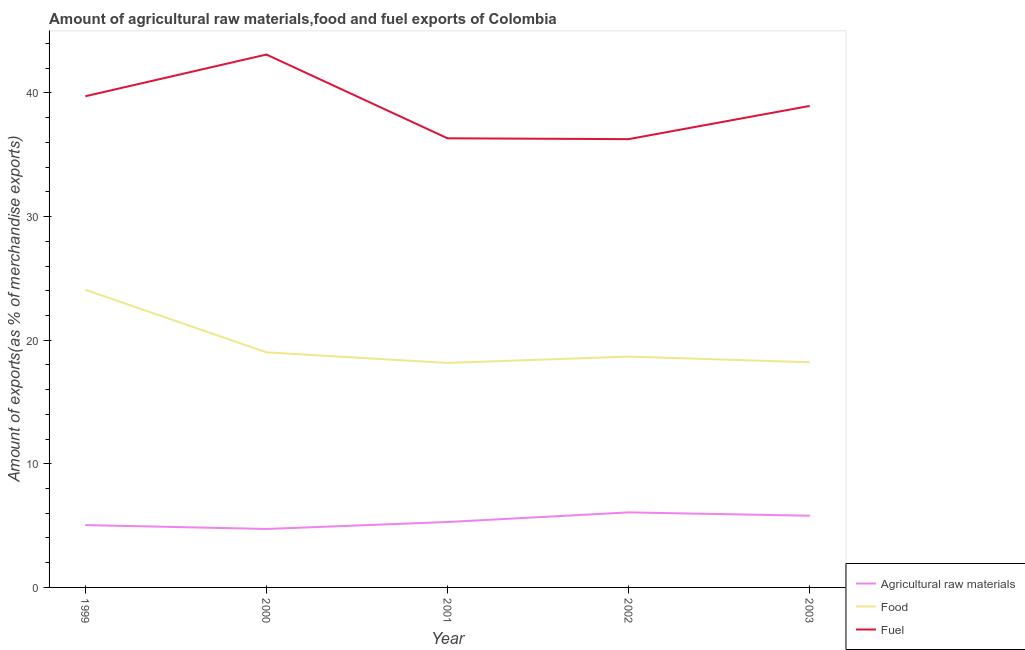How many different coloured lines are there?
Your answer should be very brief. 3. Does the line corresponding to percentage of food exports intersect with the line corresponding to percentage of fuel exports?
Your response must be concise. No. What is the percentage of raw materials exports in 2003?
Offer a very short reply. 5.8. Across all years, what is the maximum percentage of food exports?
Provide a short and direct response. 24.08. Across all years, what is the minimum percentage of fuel exports?
Offer a terse response. 36.27. In which year was the percentage of food exports maximum?
Offer a terse response. 1999. In which year was the percentage of fuel exports minimum?
Offer a terse response. 2002. What is the total percentage of fuel exports in the graph?
Your response must be concise. 194.4. What is the difference between the percentage of food exports in 2000 and that in 2001?
Provide a succinct answer. 0.86. What is the difference between the percentage of fuel exports in 2002 and the percentage of food exports in 2000?
Your answer should be compact. 17.25. What is the average percentage of raw materials exports per year?
Ensure brevity in your answer.  5.39. In the year 2002, what is the difference between the percentage of food exports and percentage of raw materials exports?
Your response must be concise. 12.6. In how many years, is the percentage of food exports greater than 30 %?
Offer a terse response. 0. What is the ratio of the percentage of fuel exports in 2000 to that in 2001?
Provide a short and direct response. 1.19. What is the difference between the highest and the second highest percentage of raw materials exports?
Ensure brevity in your answer.  0.27. What is the difference between the highest and the lowest percentage of food exports?
Offer a terse response. 5.92. In how many years, is the percentage of food exports greater than the average percentage of food exports taken over all years?
Your answer should be compact. 1. Is it the case that in every year, the sum of the percentage of raw materials exports and percentage of food exports is greater than the percentage of fuel exports?
Make the answer very short. No. Is the percentage of raw materials exports strictly less than the percentage of fuel exports over the years?
Your response must be concise. Yes. How many lines are there?
Provide a short and direct response. 3. Does the graph contain grids?
Your answer should be very brief. No. Where does the legend appear in the graph?
Make the answer very short. Bottom right. How many legend labels are there?
Your answer should be compact. 3. What is the title of the graph?
Keep it short and to the point. Amount of agricultural raw materials,food and fuel exports of Colombia. What is the label or title of the Y-axis?
Keep it short and to the point. Amount of exports(as % of merchandise exports). What is the Amount of exports(as % of merchandise exports) in Agricultural raw materials in 1999?
Provide a succinct answer. 5.04. What is the Amount of exports(as % of merchandise exports) in Food in 1999?
Ensure brevity in your answer.  24.08. What is the Amount of exports(as % of merchandise exports) of Fuel in 1999?
Keep it short and to the point. 39.74. What is the Amount of exports(as % of merchandise exports) of Agricultural raw materials in 2000?
Offer a terse response. 4.73. What is the Amount of exports(as % of merchandise exports) of Food in 2000?
Give a very brief answer. 19.02. What is the Amount of exports(as % of merchandise exports) in Fuel in 2000?
Provide a short and direct response. 43.11. What is the Amount of exports(as % of merchandise exports) in Agricultural raw materials in 2001?
Offer a very short reply. 5.29. What is the Amount of exports(as % of merchandise exports) in Food in 2001?
Provide a short and direct response. 18.16. What is the Amount of exports(as % of merchandise exports) of Fuel in 2001?
Your answer should be compact. 36.33. What is the Amount of exports(as % of merchandise exports) in Agricultural raw materials in 2002?
Offer a very short reply. 6.07. What is the Amount of exports(as % of merchandise exports) of Food in 2002?
Provide a short and direct response. 18.67. What is the Amount of exports(as % of merchandise exports) of Fuel in 2002?
Provide a short and direct response. 36.27. What is the Amount of exports(as % of merchandise exports) in Agricultural raw materials in 2003?
Your response must be concise. 5.8. What is the Amount of exports(as % of merchandise exports) in Food in 2003?
Ensure brevity in your answer.  18.22. What is the Amount of exports(as % of merchandise exports) of Fuel in 2003?
Give a very brief answer. 38.95. Across all years, what is the maximum Amount of exports(as % of merchandise exports) in Agricultural raw materials?
Your answer should be very brief. 6.07. Across all years, what is the maximum Amount of exports(as % of merchandise exports) in Food?
Make the answer very short. 24.08. Across all years, what is the maximum Amount of exports(as % of merchandise exports) of Fuel?
Keep it short and to the point. 43.11. Across all years, what is the minimum Amount of exports(as % of merchandise exports) in Agricultural raw materials?
Your response must be concise. 4.73. Across all years, what is the minimum Amount of exports(as % of merchandise exports) of Food?
Make the answer very short. 18.16. Across all years, what is the minimum Amount of exports(as % of merchandise exports) in Fuel?
Provide a short and direct response. 36.27. What is the total Amount of exports(as % of merchandise exports) of Agricultural raw materials in the graph?
Your answer should be compact. 26.94. What is the total Amount of exports(as % of merchandise exports) in Food in the graph?
Make the answer very short. 98.15. What is the total Amount of exports(as % of merchandise exports) of Fuel in the graph?
Ensure brevity in your answer.  194.4. What is the difference between the Amount of exports(as % of merchandise exports) of Agricultural raw materials in 1999 and that in 2000?
Your response must be concise. 0.32. What is the difference between the Amount of exports(as % of merchandise exports) of Food in 1999 and that in 2000?
Offer a terse response. 5.07. What is the difference between the Amount of exports(as % of merchandise exports) of Fuel in 1999 and that in 2000?
Your answer should be very brief. -3.37. What is the difference between the Amount of exports(as % of merchandise exports) of Agricultural raw materials in 1999 and that in 2001?
Offer a very short reply. -0.25. What is the difference between the Amount of exports(as % of merchandise exports) of Food in 1999 and that in 2001?
Make the answer very short. 5.92. What is the difference between the Amount of exports(as % of merchandise exports) in Fuel in 1999 and that in 2001?
Your answer should be compact. 3.4. What is the difference between the Amount of exports(as % of merchandise exports) in Agricultural raw materials in 1999 and that in 2002?
Your answer should be very brief. -1.03. What is the difference between the Amount of exports(as % of merchandise exports) of Food in 1999 and that in 2002?
Provide a short and direct response. 5.41. What is the difference between the Amount of exports(as % of merchandise exports) in Fuel in 1999 and that in 2002?
Provide a succinct answer. 3.47. What is the difference between the Amount of exports(as % of merchandise exports) of Agricultural raw materials in 1999 and that in 2003?
Give a very brief answer. -0.76. What is the difference between the Amount of exports(as % of merchandise exports) in Food in 1999 and that in 2003?
Your response must be concise. 5.87. What is the difference between the Amount of exports(as % of merchandise exports) of Fuel in 1999 and that in 2003?
Provide a short and direct response. 0.78. What is the difference between the Amount of exports(as % of merchandise exports) of Agricultural raw materials in 2000 and that in 2001?
Give a very brief answer. -0.56. What is the difference between the Amount of exports(as % of merchandise exports) in Food in 2000 and that in 2001?
Provide a succinct answer. 0.86. What is the difference between the Amount of exports(as % of merchandise exports) in Fuel in 2000 and that in 2001?
Provide a succinct answer. 6.78. What is the difference between the Amount of exports(as % of merchandise exports) of Agricultural raw materials in 2000 and that in 2002?
Ensure brevity in your answer.  -1.34. What is the difference between the Amount of exports(as % of merchandise exports) in Food in 2000 and that in 2002?
Provide a short and direct response. 0.34. What is the difference between the Amount of exports(as % of merchandise exports) of Fuel in 2000 and that in 2002?
Your answer should be compact. 6.84. What is the difference between the Amount of exports(as % of merchandise exports) of Agricultural raw materials in 2000 and that in 2003?
Give a very brief answer. -1.07. What is the difference between the Amount of exports(as % of merchandise exports) of Food in 2000 and that in 2003?
Make the answer very short. 0.8. What is the difference between the Amount of exports(as % of merchandise exports) in Fuel in 2000 and that in 2003?
Your answer should be compact. 4.16. What is the difference between the Amount of exports(as % of merchandise exports) of Agricultural raw materials in 2001 and that in 2002?
Your response must be concise. -0.78. What is the difference between the Amount of exports(as % of merchandise exports) in Food in 2001 and that in 2002?
Provide a short and direct response. -0.51. What is the difference between the Amount of exports(as % of merchandise exports) of Fuel in 2001 and that in 2002?
Provide a succinct answer. 0.07. What is the difference between the Amount of exports(as % of merchandise exports) of Agricultural raw materials in 2001 and that in 2003?
Your answer should be very brief. -0.51. What is the difference between the Amount of exports(as % of merchandise exports) in Food in 2001 and that in 2003?
Your answer should be compact. -0.06. What is the difference between the Amount of exports(as % of merchandise exports) in Fuel in 2001 and that in 2003?
Your answer should be compact. -2.62. What is the difference between the Amount of exports(as % of merchandise exports) in Agricultural raw materials in 2002 and that in 2003?
Your answer should be compact. 0.27. What is the difference between the Amount of exports(as % of merchandise exports) in Food in 2002 and that in 2003?
Your response must be concise. 0.46. What is the difference between the Amount of exports(as % of merchandise exports) of Fuel in 2002 and that in 2003?
Ensure brevity in your answer.  -2.69. What is the difference between the Amount of exports(as % of merchandise exports) in Agricultural raw materials in 1999 and the Amount of exports(as % of merchandise exports) in Food in 2000?
Offer a very short reply. -13.97. What is the difference between the Amount of exports(as % of merchandise exports) in Agricultural raw materials in 1999 and the Amount of exports(as % of merchandise exports) in Fuel in 2000?
Ensure brevity in your answer.  -38.07. What is the difference between the Amount of exports(as % of merchandise exports) in Food in 1999 and the Amount of exports(as % of merchandise exports) in Fuel in 2000?
Your answer should be very brief. -19.03. What is the difference between the Amount of exports(as % of merchandise exports) of Agricultural raw materials in 1999 and the Amount of exports(as % of merchandise exports) of Food in 2001?
Offer a terse response. -13.12. What is the difference between the Amount of exports(as % of merchandise exports) of Agricultural raw materials in 1999 and the Amount of exports(as % of merchandise exports) of Fuel in 2001?
Ensure brevity in your answer.  -31.29. What is the difference between the Amount of exports(as % of merchandise exports) in Food in 1999 and the Amount of exports(as % of merchandise exports) in Fuel in 2001?
Offer a terse response. -12.25. What is the difference between the Amount of exports(as % of merchandise exports) of Agricultural raw materials in 1999 and the Amount of exports(as % of merchandise exports) of Food in 2002?
Offer a terse response. -13.63. What is the difference between the Amount of exports(as % of merchandise exports) in Agricultural raw materials in 1999 and the Amount of exports(as % of merchandise exports) in Fuel in 2002?
Make the answer very short. -31.22. What is the difference between the Amount of exports(as % of merchandise exports) of Food in 1999 and the Amount of exports(as % of merchandise exports) of Fuel in 2002?
Provide a succinct answer. -12.18. What is the difference between the Amount of exports(as % of merchandise exports) of Agricultural raw materials in 1999 and the Amount of exports(as % of merchandise exports) of Food in 2003?
Make the answer very short. -13.17. What is the difference between the Amount of exports(as % of merchandise exports) of Agricultural raw materials in 1999 and the Amount of exports(as % of merchandise exports) of Fuel in 2003?
Your answer should be very brief. -33.91. What is the difference between the Amount of exports(as % of merchandise exports) in Food in 1999 and the Amount of exports(as % of merchandise exports) in Fuel in 2003?
Give a very brief answer. -14.87. What is the difference between the Amount of exports(as % of merchandise exports) of Agricultural raw materials in 2000 and the Amount of exports(as % of merchandise exports) of Food in 2001?
Provide a succinct answer. -13.43. What is the difference between the Amount of exports(as % of merchandise exports) of Agricultural raw materials in 2000 and the Amount of exports(as % of merchandise exports) of Fuel in 2001?
Offer a very short reply. -31.61. What is the difference between the Amount of exports(as % of merchandise exports) of Food in 2000 and the Amount of exports(as % of merchandise exports) of Fuel in 2001?
Your answer should be compact. -17.32. What is the difference between the Amount of exports(as % of merchandise exports) of Agricultural raw materials in 2000 and the Amount of exports(as % of merchandise exports) of Food in 2002?
Offer a terse response. -13.94. What is the difference between the Amount of exports(as % of merchandise exports) in Agricultural raw materials in 2000 and the Amount of exports(as % of merchandise exports) in Fuel in 2002?
Offer a very short reply. -31.54. What is the difference between the Amount of exports(as % of merchandise exports) in Food in 2000 and the Amount of exports(as % of merchandise exports) in Fuel in 2002?
Keep it short and to the point. -17.25. What is the difference between the Amount of exports(as % of merchandise exports) in Agricultural raw materials in 2000 and the Amount of exports(as % of merchandise exports) in Food in 2003?
Provide a short and direct response. -13.49. What is the difference between the Amount of exports(as % of merchandise exports) of Agricultural raw materials in 2000 and the Amount of exports(as % of merchandise exports) of Fuel in 2003?
Your answer should be compact. -34.22. What is the difference between the Amount of exports(as % of merchandise exports) of Food in 2000 and the Amount of exports(as % of merchandise exports) of Fuel in 2003?
Provide a short and direct response. -19.94. What is the difference between the Amount of exports(as % of merchandise exports) of Agricultural raw materials in 2001 and the Amount of exports(as % of merchandise exports) of Food in 2002?
Offer a terse response. -13.38. What is the difference between the Amount of exports(as % of merchandise exports) in Agricultural raw materials in 2001 and the Amount of exports(as % of merchandise exports) in Fuel in 2002?
Offer a very short reply. -30.97. What is the difference between the Amount of exports(as % of merchandise exports) of Food in 2001 and the Amount of exports(as % of merchandise exports) of Fuel in 2002?
Provide a succinct answer. -18.11. What is the difference between the Amount of exports(as % of merchandise exports) in Agricultural raw materials in 2001 and the Amount of exports(as % of merchandise exports) in Food in 2003?
Offer a terse response. -12.92. What is the difference between the Amount of exports(as % of merchandise exports) of Agricultural raw materials in 2001 and the Amount of exports(as % of merchandise exports) of Fuel in 2003?
Provide a succinct answer. -33.66. What is the difference between the Amount of exports(as % of merchandise exports) in Food in 2001 and the Amount of exports(as % of merchandise exports) in Fuel in 2003?
Make the answer very short. -20.79. What is the difference between the Amount of exports(as % of merchandise exports) of Agricultural raw materials in 2002 and the Amount of exports(as % of merchandise exports) of Food in 2003?
Your response must be concise. -12.15. What is the difference between the Amount of exports(as % of merchandise exports) in Agricultural raw materials in 2002 and the Amount of exports(as % of merchandise exports) in Fuel in 2003?
Your answer should be compact. -32.88. What is the difference between the Amount of exports(as % of merchandise exports) of Food in 2002 and the Amount of exports(as % of merchandise exports) of Fuel in 2003?
Offer a terse response. -20.28. What is the average Amount of exports(as % of merchandise exports) in Agricultural raw materials per year?
Provide a succinct answer. 5.39. What is the average Amount of exports(as % of merchandise exports) of Food per year?
Your answer should be very brief. 19.63. What is the average Amount of exports(as % of merchandise exports) in Fuel per year?
Your answer should be very brief. 38.88. In the year 1999, what is the difference between the Amount of exports(as % of merchandise exports) of Agricultural raw materials and Amount of exports(as % of merchandise exports) of Food?
Provide a succinct answer. -19.04. In the year 1999, what is the difference between the Amount of exports(as % of merchandise exports) of Agricultural raw materials and Amount of exports(as % of merchandise exports) of Fuel?
Your answer should be compact. -34.69. In the year 1999, what is the difference between the Amount of exports(as % of merchandise exports) of Food and Amount of exports(as % of merchandise exports) of Fuel?
Provide a succinct answer. -15.65. In the year 2000, what is the difference between the Amount of exports(as % of merchandise exports) in Agricultural raw materials and Amount of exports(as % of merchandise exports) in Food?
Offer a terse response. -14.29. In the year 2000, what is the difference between the Amount of exports(as % of merchandise exports) of Agricultural raw materials and Amount of exports(as % of merchandise exports) of Fuel?
Provide a short and direct response. -38.38. In the year 2000, what is the difference between the Amount of exports(as % of merchandise exports) in Food and Amount of exports(as % of merchandise exports) in Fuel?
Offer a very short reply. -24.09. In the year 2001, what is the difference between the Amount of exports(as % of merchandise exports) in Agricultural raw materials and Amount of exports(as % of merchandise exports) in Food?
Keep it short and to the point. -12.87. In the year 2001, what is the difference between the Amount of exports(as % of merchandise exports) of Agricultural raw materials and Amount of exports(as % of merchandise exports) of Fuel?
Provide a succinct answer. -31.04. In the year 2001, what is the difference between the Amount of exports(as % of merchandise exports) in Food and Amount of exports(as % of merchandise exports) in Fuel?
Give a very brief answer. -18.17. In the year 2002, what is the difference between the Amount of exports(as % of merchandise exports) of Agricultural raw materials and Amount of exports(as % of merchandise exports) of Food?
Keep it short and to the point. -12.6. In the year 2002, what is the difference between the Amount of exports(as % of merchandise exports) of Agricultural raw materials and Amount of exports(as % of merchandise exports) of Fuel?
Provide a succinct answer. -30.2. In the year 2002, what is the difference between the Amount of exports(as % of merchandise exports) in Food and Amount of exports(as % of merchandise exports) in Fuel?
Ensure brevity in your answer.  -17.59. In the year 2003, what is the difference between the Amount of exports(as % of merchandise exports) of Agricultural raw materials and Amount of exports(as % of merchandise exports) of Food?
Ensure brevity in your answer.  -12.42. In the year 2003, what is the difference between the Amount of exports(as % of merchandise exports) in Agricultural raw materials and Amount of exports(as % of merchandise exports) in Fuel?
Ensure brevity in your answer.  -33.15. In the year 2003, what is the difference between the Amount of exports(as % of merchandise exports) in Food and Amount of exports(as % of merchandise exports) in Fuel?
Provide a succinct answer. -20.74. What is the ratio of the Amount of exports(as % of merchandise exports) in Agricultural raw materials in 1999 to that in 2000?
Make the answer very short. 1.07. What is the ratio of the Amount of exports(as % of merchandise exports) in Food in 1999 to that in 2000?
Your answer should be very brief. 1.27. What is the ratio of the Amount of exports(as % of merchandise exports) in Fuel in 1999 to that in 2000?
Your answer should be very brief. 0.92. What is the ratio of the Amount of exports(as % of merchandise exports) in Agricultural raw materials in 1999 to that in 2001?
Provide a succinct answer. 0.95. What is the ratio of the Amount of exports(as % of merchandise exports) in Food in 1999 to that in 2001?
Keep it short and to the point. 1.33. What is the ratio of the Amount of exports(as % of merchandise exports) of Fuel in 1999 to that in 2001?
Provide a short and direct response. 1.09. What is the ratio of the Amount of exports(as % of merchandise exports) in Agricultural raw materials in 1999 to that in 2002?
Ensure brevity in your answer.  0.83. What is the ratio of the Amount of exports(as % of merchandise exports) of Food in 1999 to that in 2002?
Give a very brief answer. 1.29. What is the ratio of the Amount of exports(as % of merchandise exports) in Fuel in 1999 to that in 2002?
Give a very brief answer. 1.1. What is the ratio of the Amount of exports(as % of merchandise exports) of Agricultural raw materials in 1999 to that in 2003?
Your response must be concise. 0.87. What is the ratio of the Amount of exports(as % of merchandise exports) in Food in 1999 to that in 2003?
Your answer should be compact. 1.32. What is the ratio of the Amount of exports(as % of merchandise exports) in Fuel in 1999 to that in 2003?
Your response must be concise. 1.02. What is the ratio of the Amount of exports(as % of merchandise exports) of Agricultural raw materials in 2000 to that in 2001?
Ensure brevity in your answer.  0.89. What is the ratio of the Amount of exports(as % of merchandise exports) in Food in 2000 to that in 2001?
Ensure brevity in your answer.  1.05. What is the ratio of the Amount of exports(as % of merchandise exports) of Fuel in 2000 to that in 2001?
Make the answer very short. 1.19. What is the ratio of the Amount of exports(as % of merchandise exports) of Agricultural raw materials in 2000 to that in 2002?
Your answer should be very brief. 0.78. What is the ratio of the Amount of exports(as % of merchandise exports) of Food in 2000 to that in 2002?
Keep it short and to the point. 1.02. What is the ratio of the Amount of exports(as % of merchandise exports) in Fuel in 2000 to that in 2002?
Keep it short and to the point. 1.19. What is the ratio of the Amount of exports(as % of merchandise exports) of Agricultural raw materials in 2000 to that in 2003?
Offer a terse response. 0.82. What is the ratio of the Amount of exports(as % of merchandise exports) in Food in 2000 to that in 2003?
Your answer should be compact. 1.04. What is the ratio of the Amount of exports(as % of merchandise exports) in Fuel in 2000 to that in 2003?
Provide a succinct answer. 1.11. What is the ratio of the Amount of exports(as % of merchandise exports) in Agricultural raw materials in 2001 to that in 2002?
Your answer should be compact. 0.87. What is the ratio of the Amount of exports(as % of merchandise exports) in Food in 2001 to that in 2002?
Provide a short and direct response. 0.97. What is the ratio of the Amount of exports(as % of merchandise exports) of Agricultural raw materials in 2001 to that in 2003?
Your answer should be compact. 0.91. What is the ratio of the Amount of exports(as % of merchandise exports) in Food in 2001 to that in 2003?
Give a very brief answer. 1. What is the ratio of the Amount of exports(as % of merchandise exports) of Fuel in 2001 to that in 2003?
Offer a very short reply. 0.93. What is the ratio of the Amount of exports(as % of merchandise exports) of Agricultural raw materials in 2002 to that in 2003?
Provide a succinct answer. 1.05. What is the ratio of the Amount of exports(as % of merchandise exports) of Food in 2002 to that in 2003?
Offer a terse response. 1.03. What is the ratio of the Amount of exports(as % of merchandise exports) of Fuel in 2002 to that in 2003?
Ensure brevity in your answer.  0.93. What is the difference between the highest and the second highest Amount of exports(as % of merchandise exports) in Agricultural raw materials?
Provide a succinct answer. 0.27. What is the difference between the highest and the second highest Amount of exports(as % of merchandise exports) of Food?
Your response must be concise. 5.07. What is the difference between the highest and the second highest Amount of exports(as % of merchandise exports) in Fuel?
Provide a short and direct response. 3.37. What is the difference between the highest and the lowest Amount of exports(as % of merchandise exports) in Agricultural raw materials?
Provide a short and direct response. 1.34. What is the difference between the highest and the lowest Amount of exports(as % of merchandise exports) in Food?
Offer a terse response. 5.92. What is the difference between the highest and the lowest Amount of exports(as % of merchandise exports) in Fuel?
Keep it short and to the point. 6.84. 